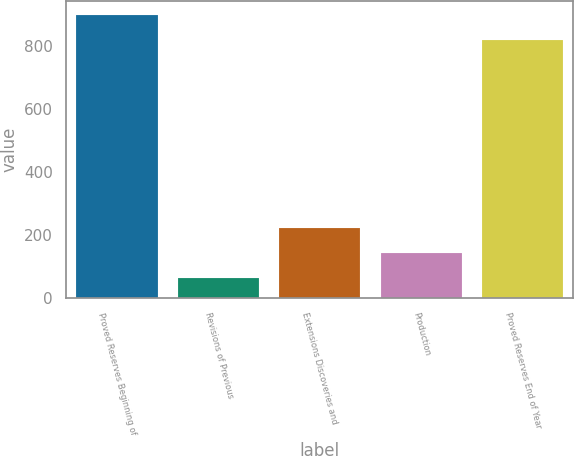Convert chart to OTSL. <chart><loc_0><loc_0><loc_500><loc_500><bar_chart><fcel>Proved Reserves Beginning of<fcel>Revisions of Previous<fcel>Extensions Discoveries and<fcel>Production<fcel>Proved Reserves End of Year<nl><fcel>900<fcel>64<fcel>224<fcel>144<fcel>820<nl></chart> 